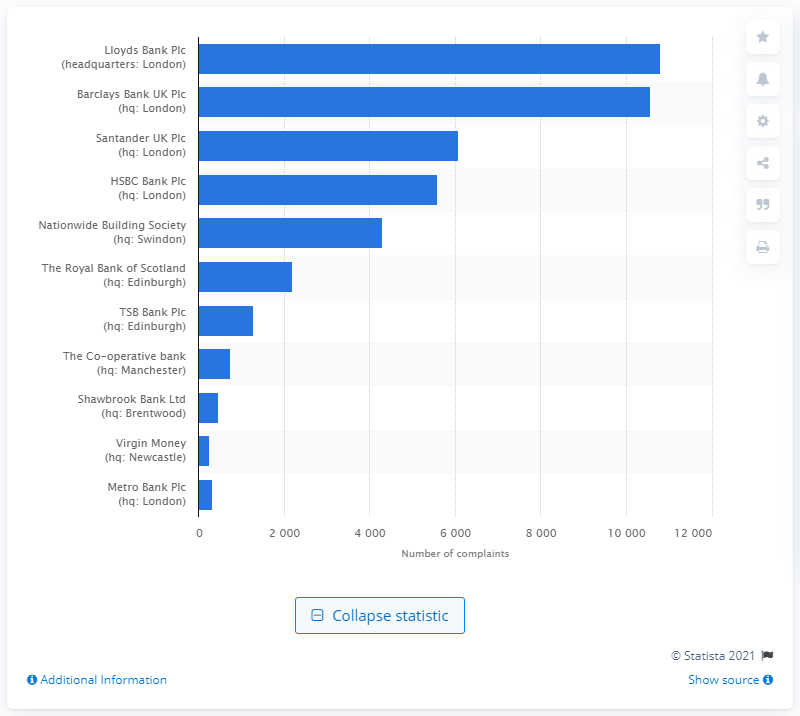Mention a couple of crucial points in this snapshot. In the second half of 2019, a total of 10,813 complaints were filed against Lloyds Bank Plc. In the second half of 2019, a total of 10,578 complaints were filed against Barclays Bank Plc. 